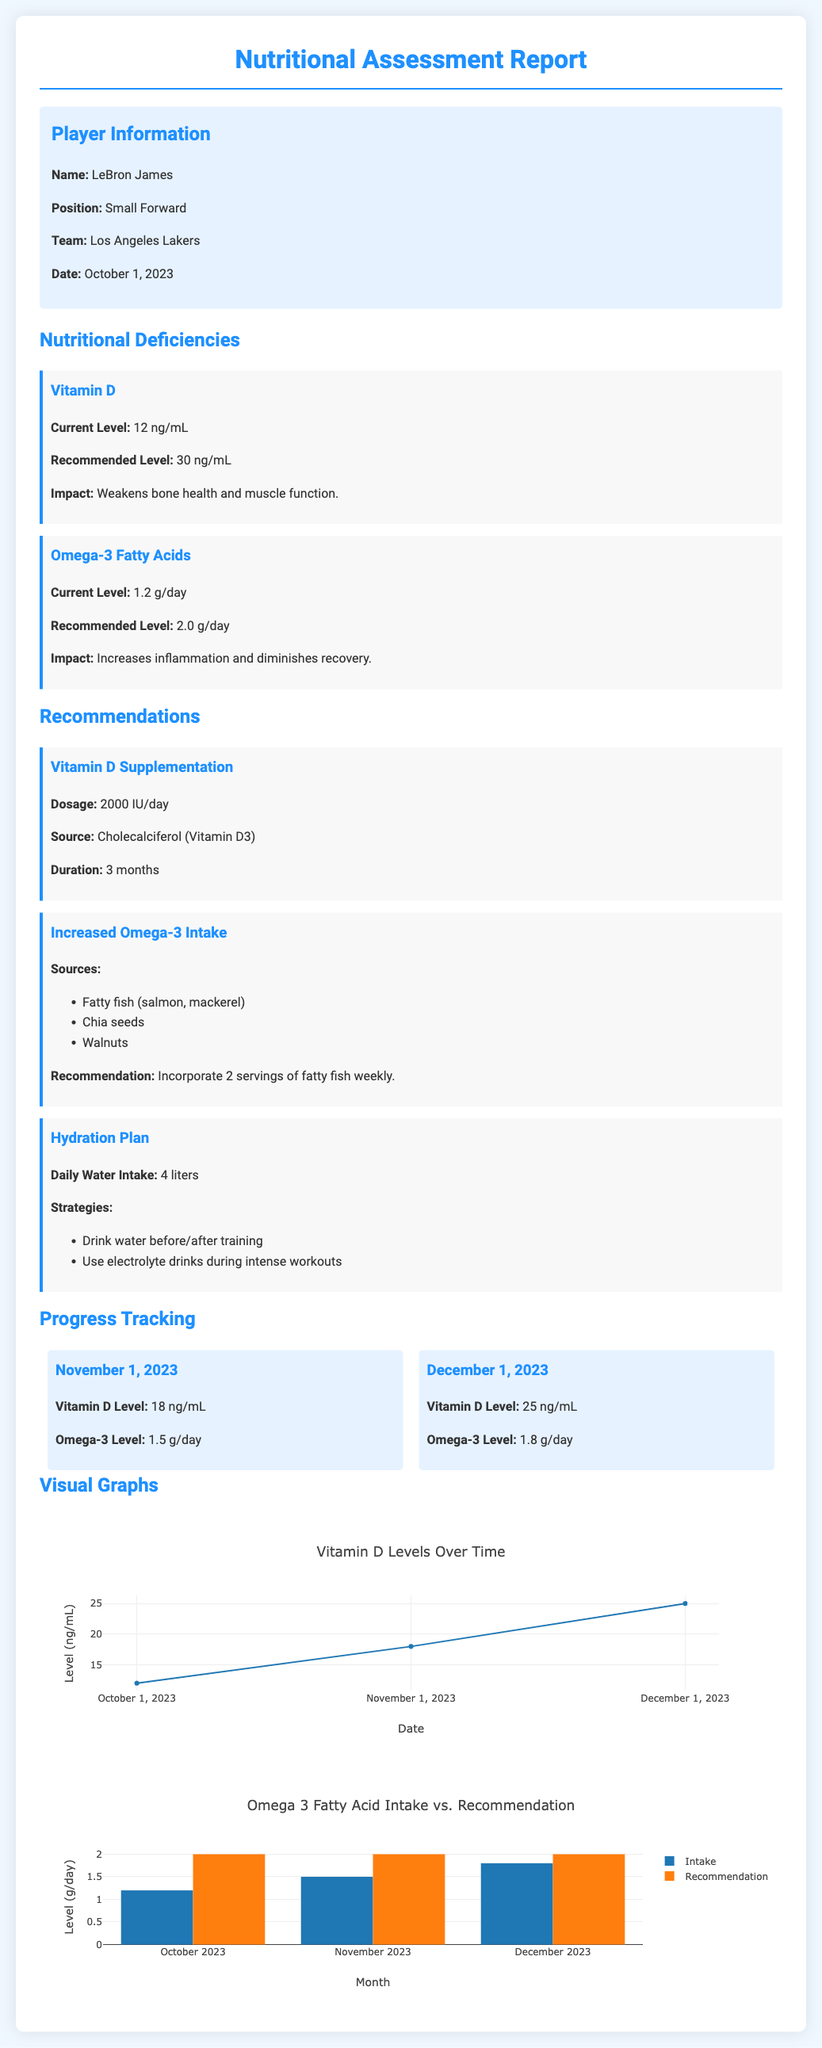What is the player's name? The player's name is stated clearly in the report's header section.
Answer: LeBron James What is LeBron James' current level of Vitamin D? The document provides specific current values for Vitamin D in the nutritional deficiencies section.
Answer: 12 ng/mL What is the recommended dosage for Vitamin D supplementation? The recommendation section clearly specifies the dosage for Vitamin D.
Answer: 2000 IU/day What is the target level for Omega-3 fatty acids? The nutritional deficiencies section outlines the recommended intake level for Omega-3 fatty acids.
Answer: 2.0 g/day What date is the nutritional assessment report dated? The date of the report is provided in the player information section.
Answer: October 1, 2023 What was LeBron's Vitamin D level on November 1, 2023? The progress tracking section lists specific Vitamin D levels on consecutive dates.
Answer: 18 ng/mL Which food sources are recommended to increase Omega-3 intake? The recommendation section lists specific food sources to enhance Omega-3 fatty acid intake.
Answer: Fatty fish, chia seeds, walnuts What type of visual representation is used for Vitamin D levels? The document describes visual representations included for different nutrients and their levels.
Answer: Scatter plot How many liters of water is recommended for daily intake? The hydration plan section provides a specific amount for daily water intake.
Answer: 4 liters 